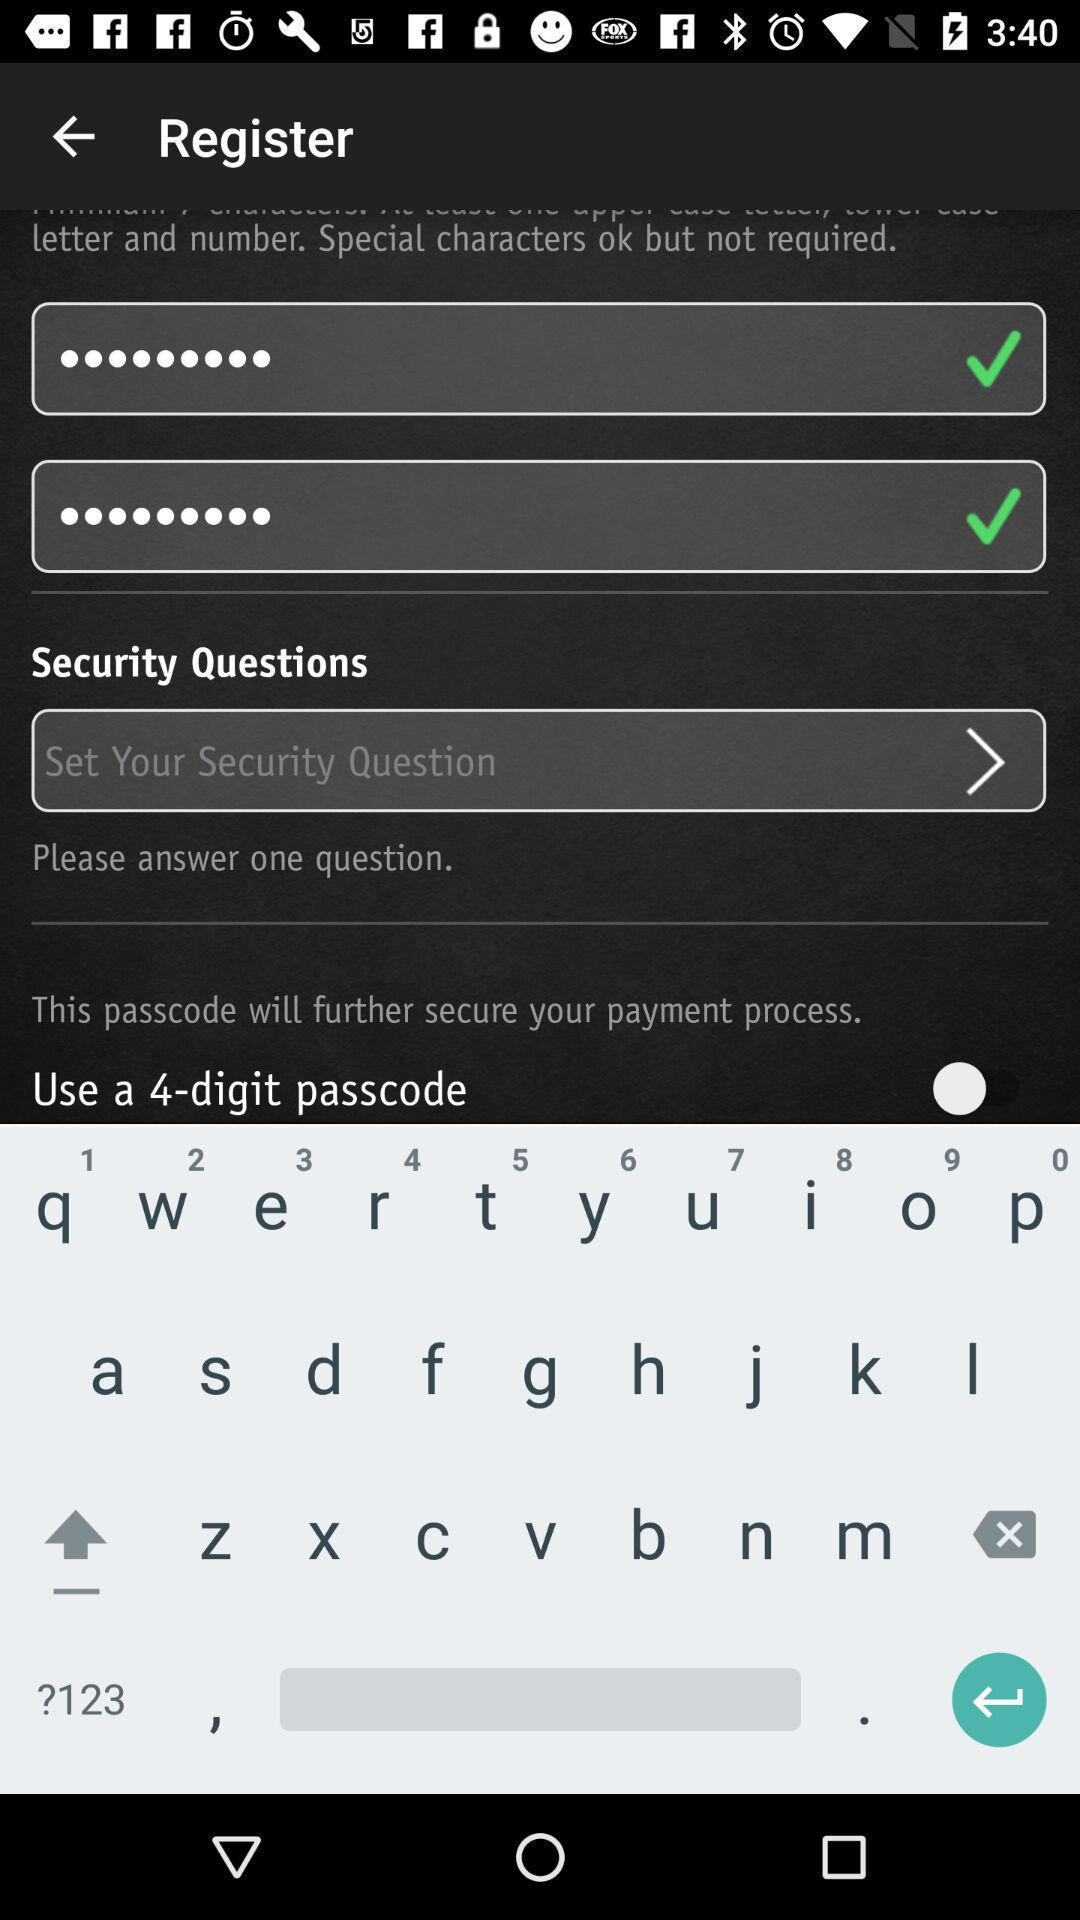How many more text inputs are there than security questions?
Answer the question using a single word or phrase. 2 